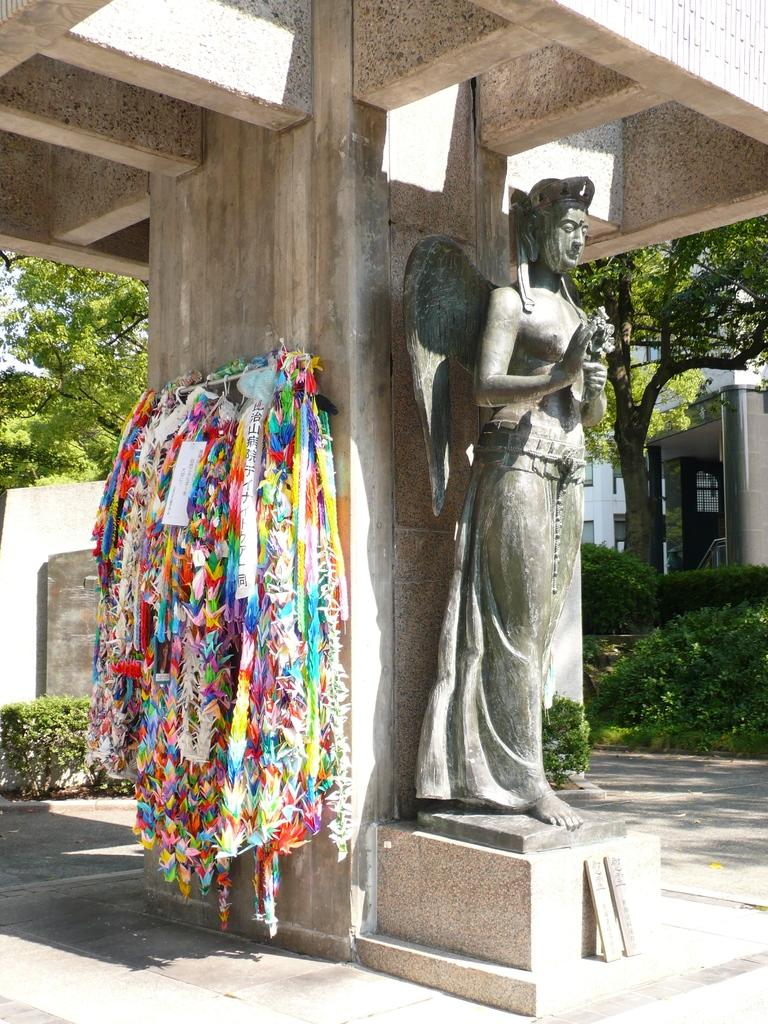What is the main subject of the image? The main subject of the image is a building. What can be seen in the foreground of the image? There is a statue and other objects in the foreground. What is visible in the background of the image? There is another building and trees in the background. What is visible at the top of the image? The sky is visible at the top of the image. What type of mint is growing near the statue in the image? There is no mint present in the image; it features a building, a statue, and other objects in the foreground, as well as a building, trees, and the sky in the background. 